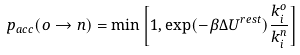<formula> <loc_0><loc_0><loc_500><loc_500>p _ { a c c } ( o \rightarrow n ) = \min \left [ 1 , \exp ( - \beta \Delta U ^ { r e s t } ) \frac { k _ { i } ^ { o } } { k _ { i } ^ { n } } \right ]</formula> 